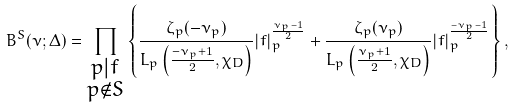Convert formula to latex. <formula><loc_0><loc_0><loc_500><loc_500>{ B } ^ { S } ( \nu ; \Delta ) = \prod _ { \substack { p | f \\ p \not \in S } } \left \{ \frac { \zeta _ { p } ( - \nu _ { p } ) } { L _ { p } \left ( \frac { - \nu _ { p } + 1 } { 2 } , \chi _ { D } \right ) } | f | _ { p } ^ { \frac { \nu _ { p } - 1 } { 2 } } + \frac { \zeta _ { p } ( \nu _ { p } ) } { L _ { p } \left ( \frac { \nu _ { p } + 1 } { 2 } , \chi _ { D } \right ) } | f | _ { p } ^ { \frac { - \nu _ { p } - 1 } { 2 } } \right \} ,</formula> 